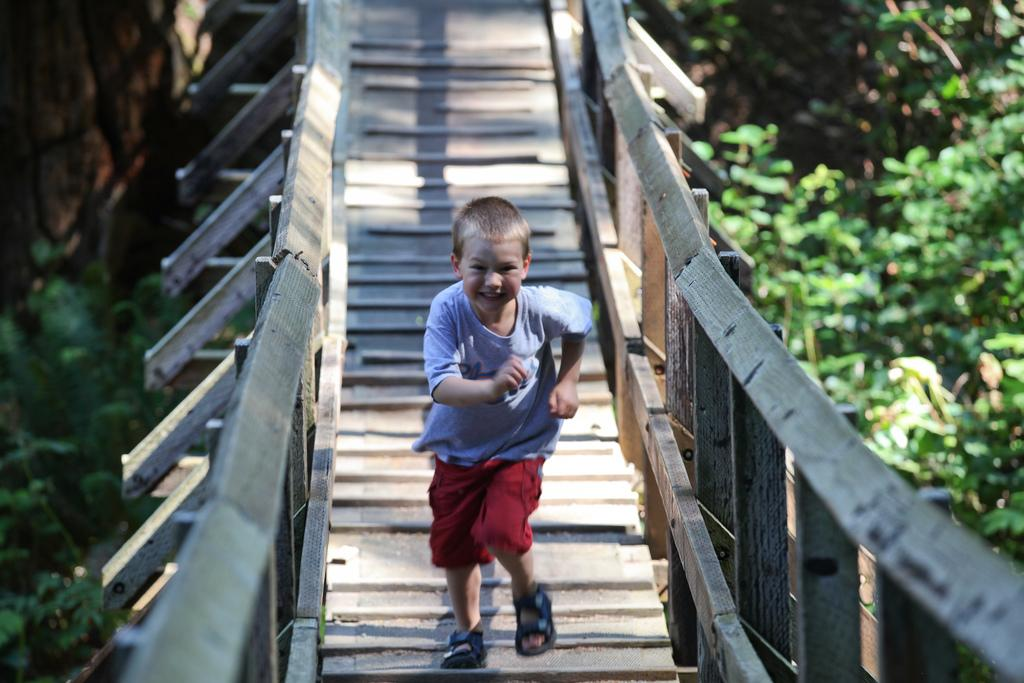Who is the main subject in the image? There is a boy in the image. What is the boy doing in the image? The boy is running in the image. Where is the boy running? The boy is running on a wooden bridge in the image. What can be seen in the background of the image? There are trees in the background of the image. What type of coast can be seen in the image? There is no coast visible in the image; it features a boy running on a wooden bridge with trees in the background. 